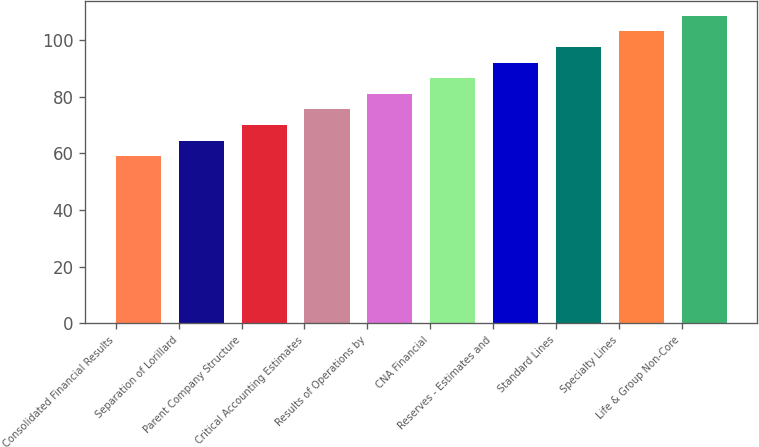Convert chart to OTSL. <chart><loc_0><loc_0><loc_500><loc_500><bar_chart><fcel>Consolidated Financial Results<fcel>Separation of Lorillard<fcel>Parent Company Structure<fcel>Critical Accounting Estimates<fcel>Results of Operations by<fcel>CNA Financial<fcel>Reserves - Estimates and<fcel>Standard Lines<fcel>Specialty Lines<fcel>Life & Group Non-Core<nl><fcel>59<fcel>64.5<fcel>70<fcel>75.5<fcel>81<fcel>86.5<fcel>92<fcel>97.5<fcel>103<fcel>108.5<nl></chart> 